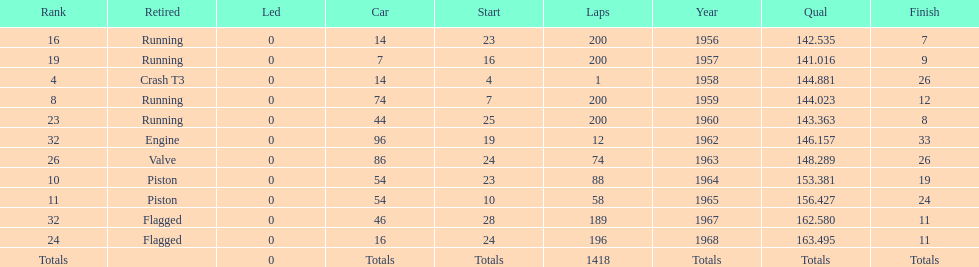Tell me the number of times he finished above 10th place. 3. 